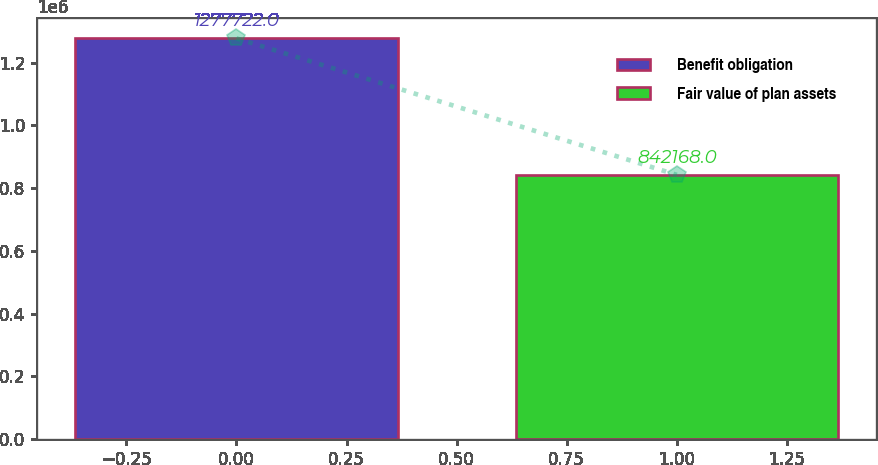Convert chart to OTSL. <chart><loc_0><loc_0><loc_500><loc_500><bar_chart><fcel>Benefit obligation<fcel>Fair value of plan assets<nl><fcel>1.27772e+06<fcel>842168<nl></chart> 